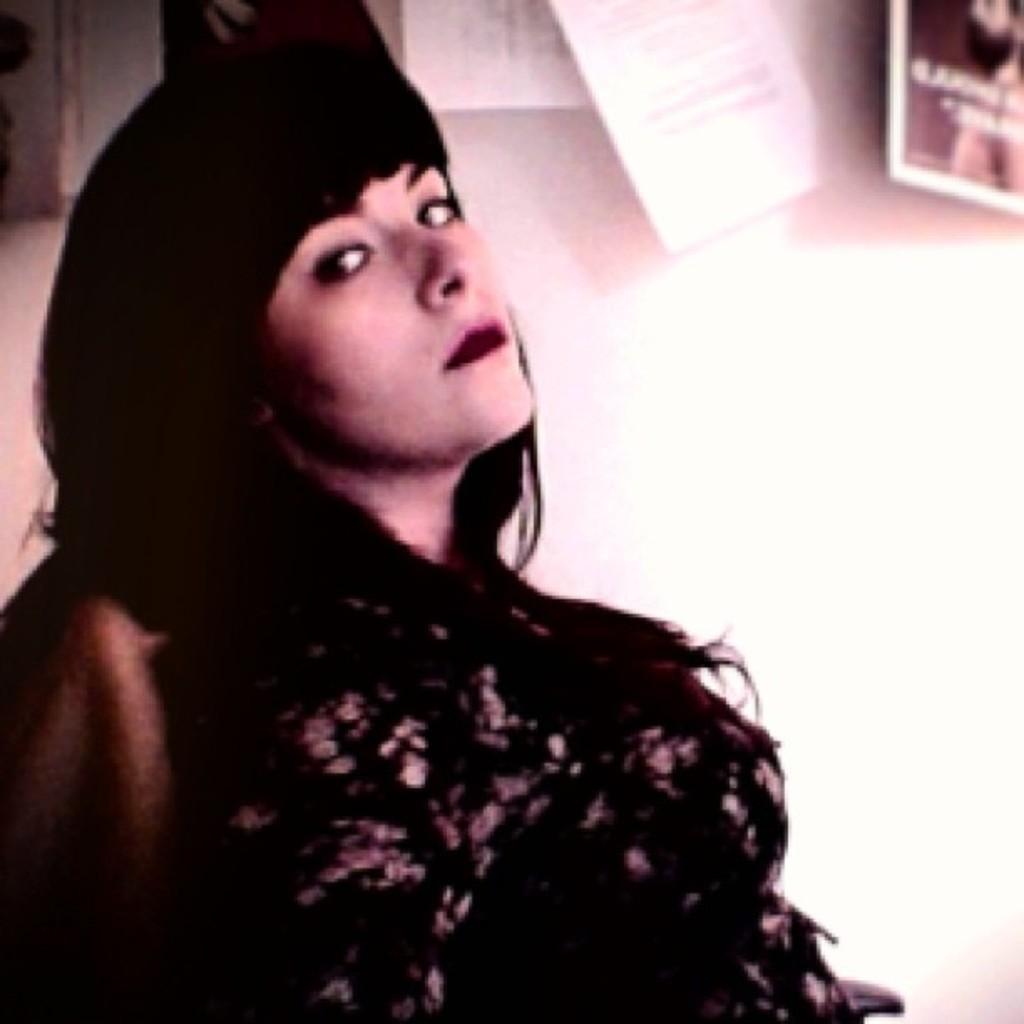Describe this image in one or two sentences. As we can see in the image there is a white color wall, papers, a woman wearing black color dress and sitting on sofa. 